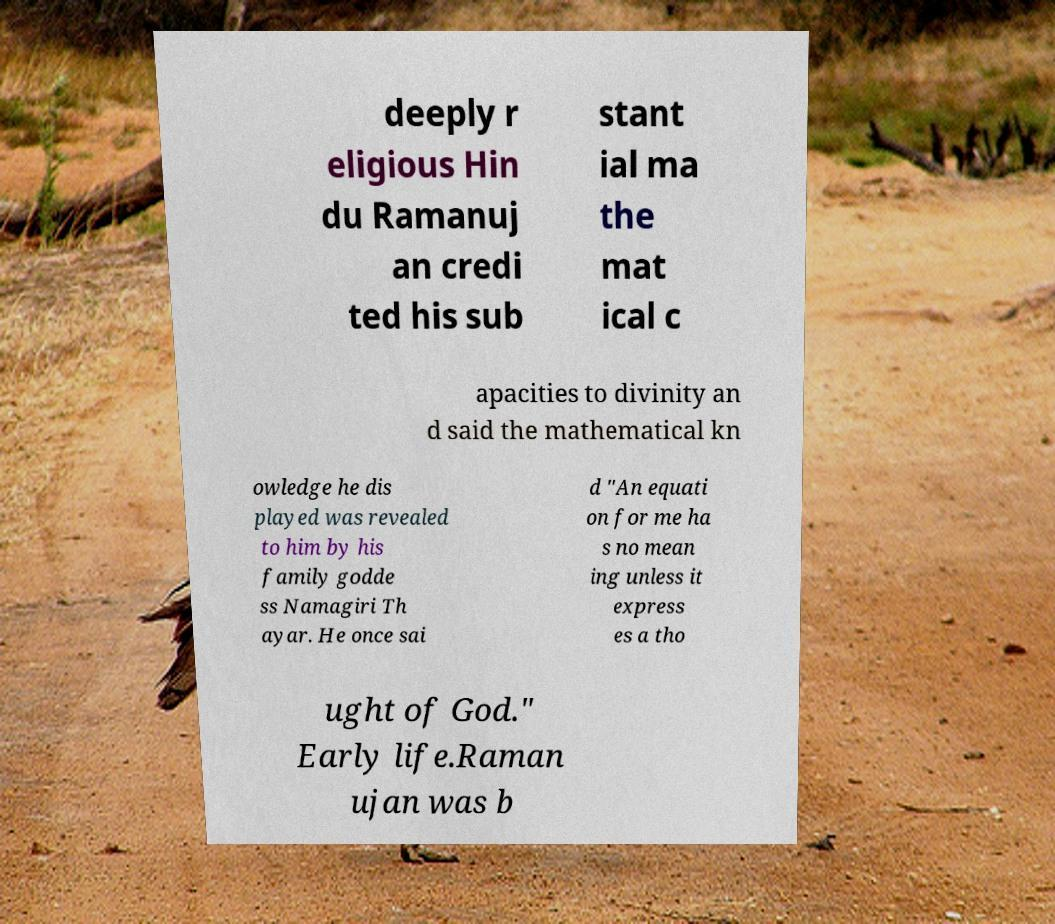Can you read and provide the text displayed in the image?This photo seems to have some interesting text. Can you extract and type it out for me? deeply r eligious Hin du Ramanuj an credi ted his sub stant ial ma the mat ical c apacities to divinity an d said the mathematical kn owledge he dis played was revealed to him by his family godde ss Namagiri Th ayar. He once sai d "An equati on for me ha s no mean ing unless it express es a tho ught of God." Early life.Raman ujan was b 